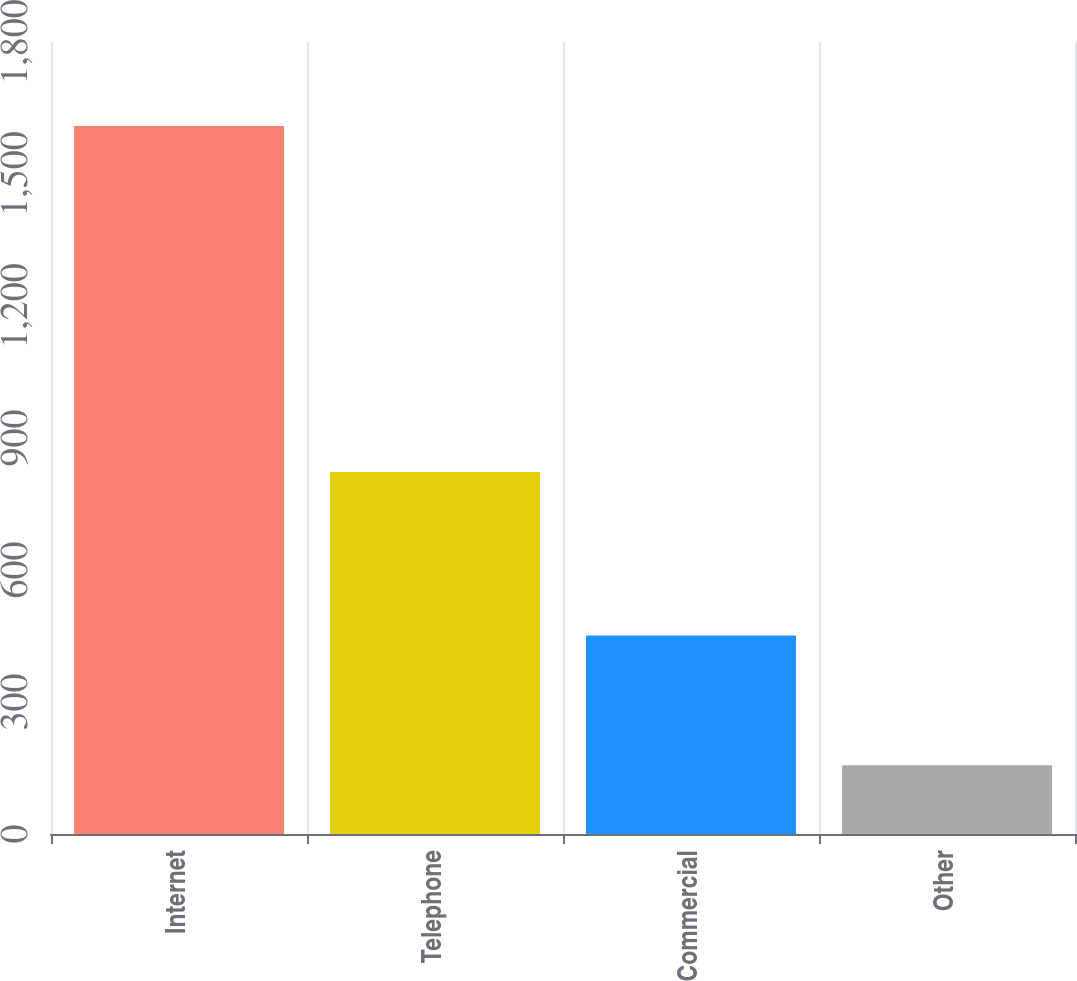<chart> <loc_0><loc_0><loc_500><loc_500><bar_chart><fcel>Internet<fcel>Telephone<fcel>Commercial<fcel>Other<nl><fcel>1609<fcel>823<fcel>451<fcel>156<nl></chart> 